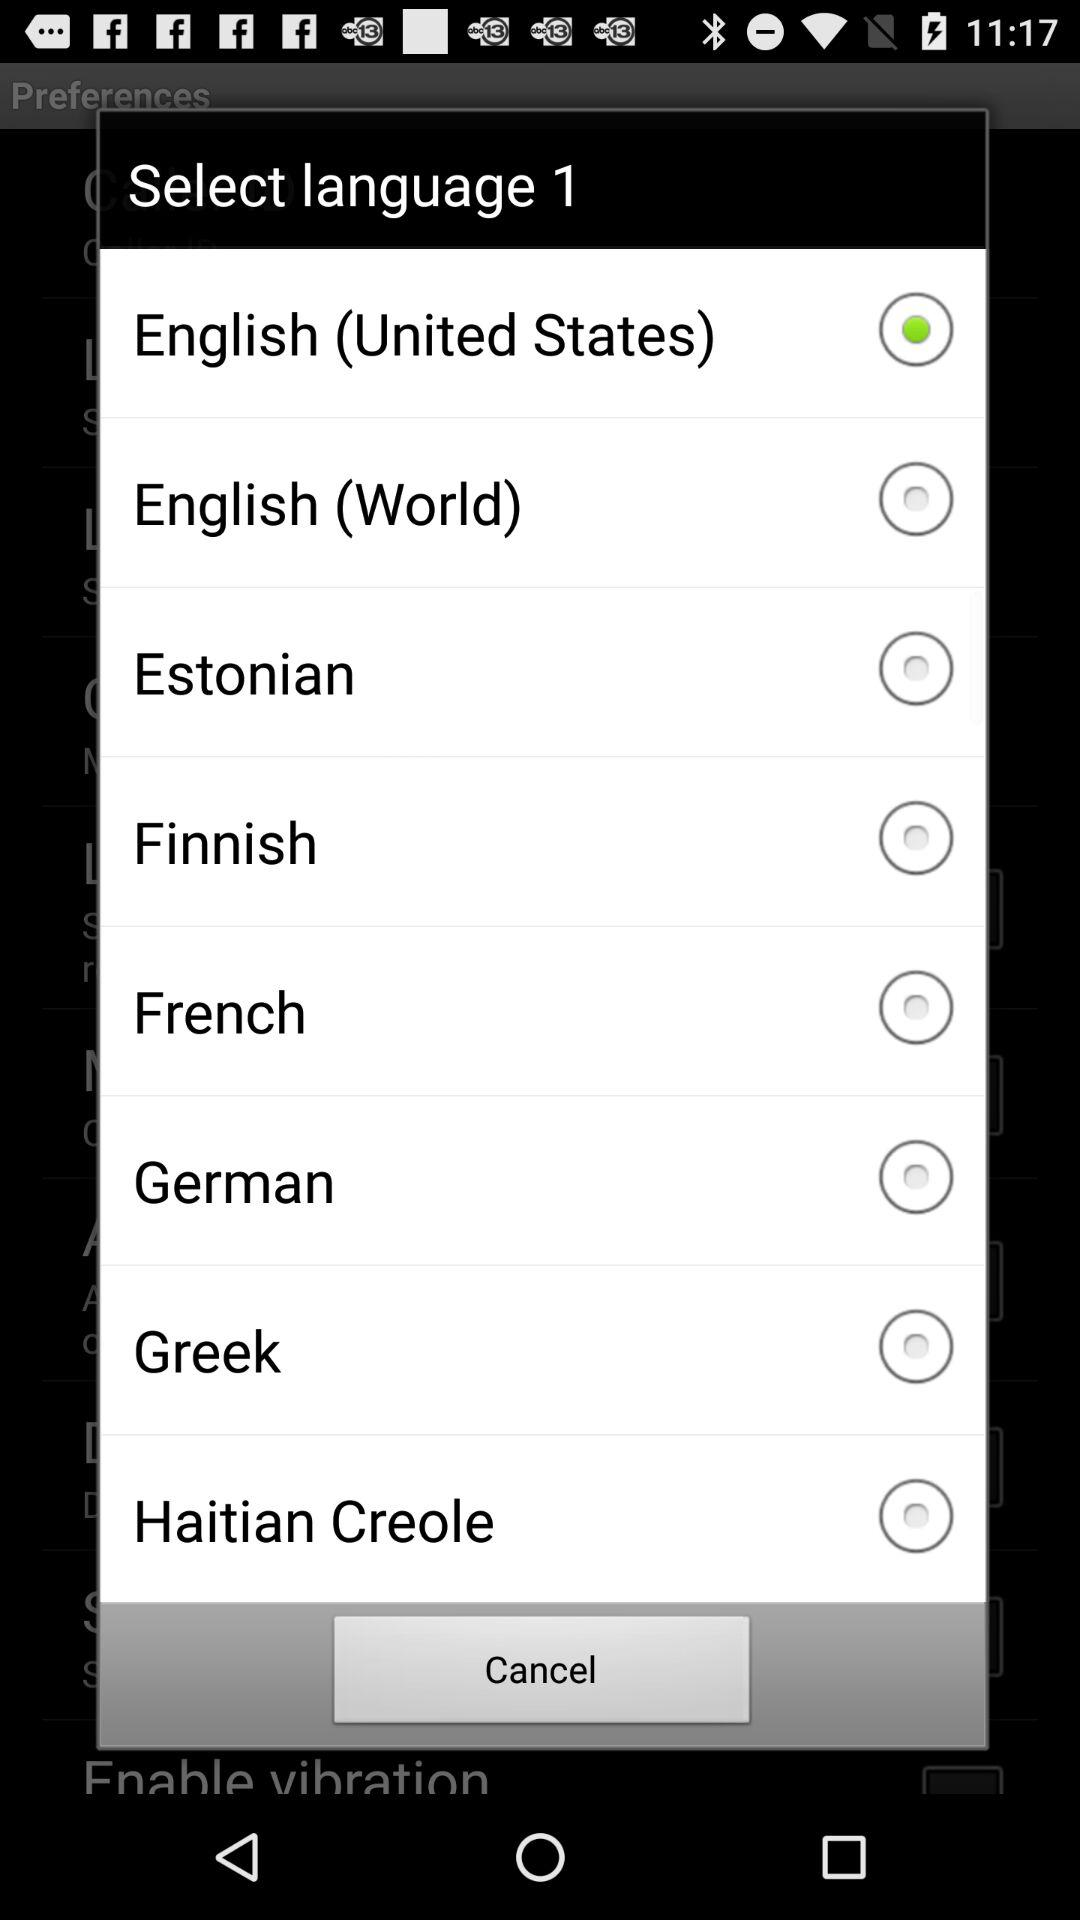Which option is selected in "Select language 1"? The selected option is English (United States). 